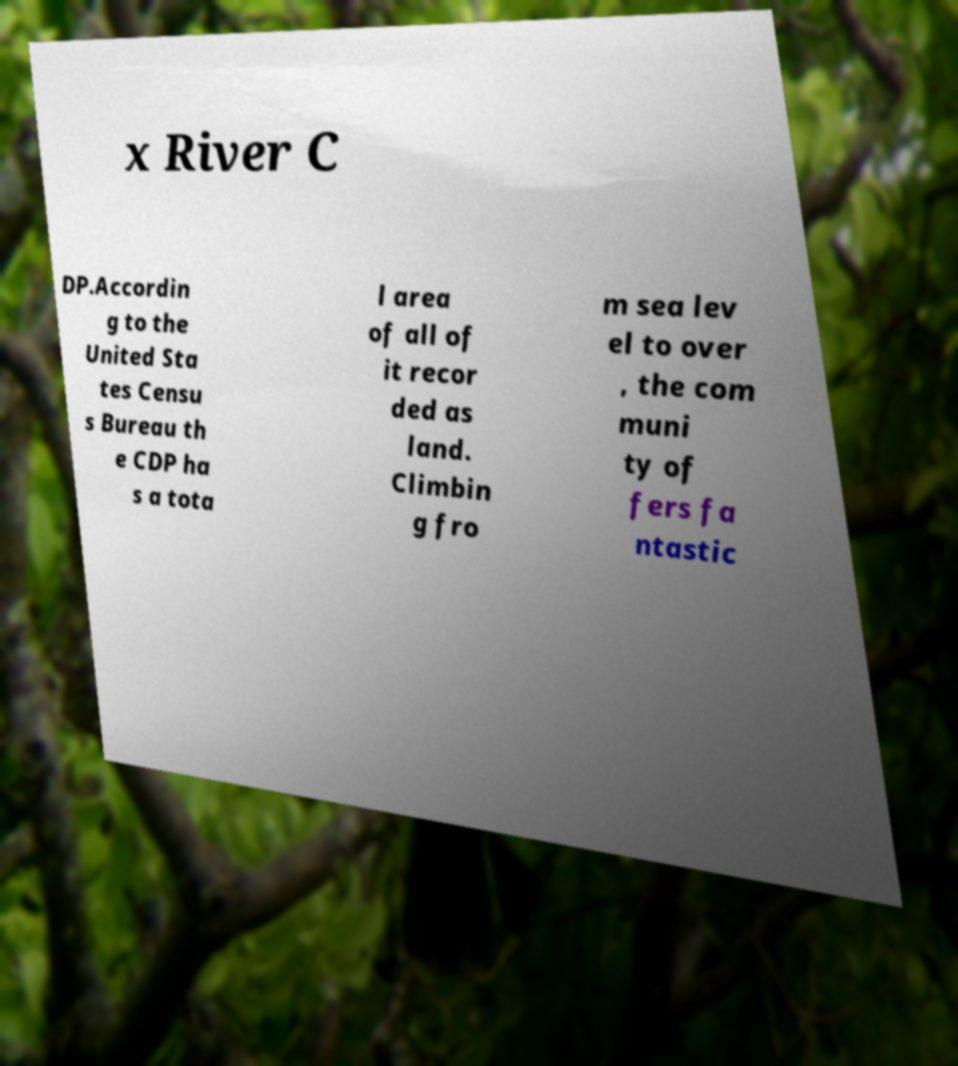What messages or text are displayed in this image? I need them in a readable, typed format. x River C DP.Accordin g to the United Sta tes Censu s Bureau th e CDP ha s a tota l area of all of it recor ded as land. Climbin g fro m sea lev el to over , the com muni ty of fers fa ntastic 